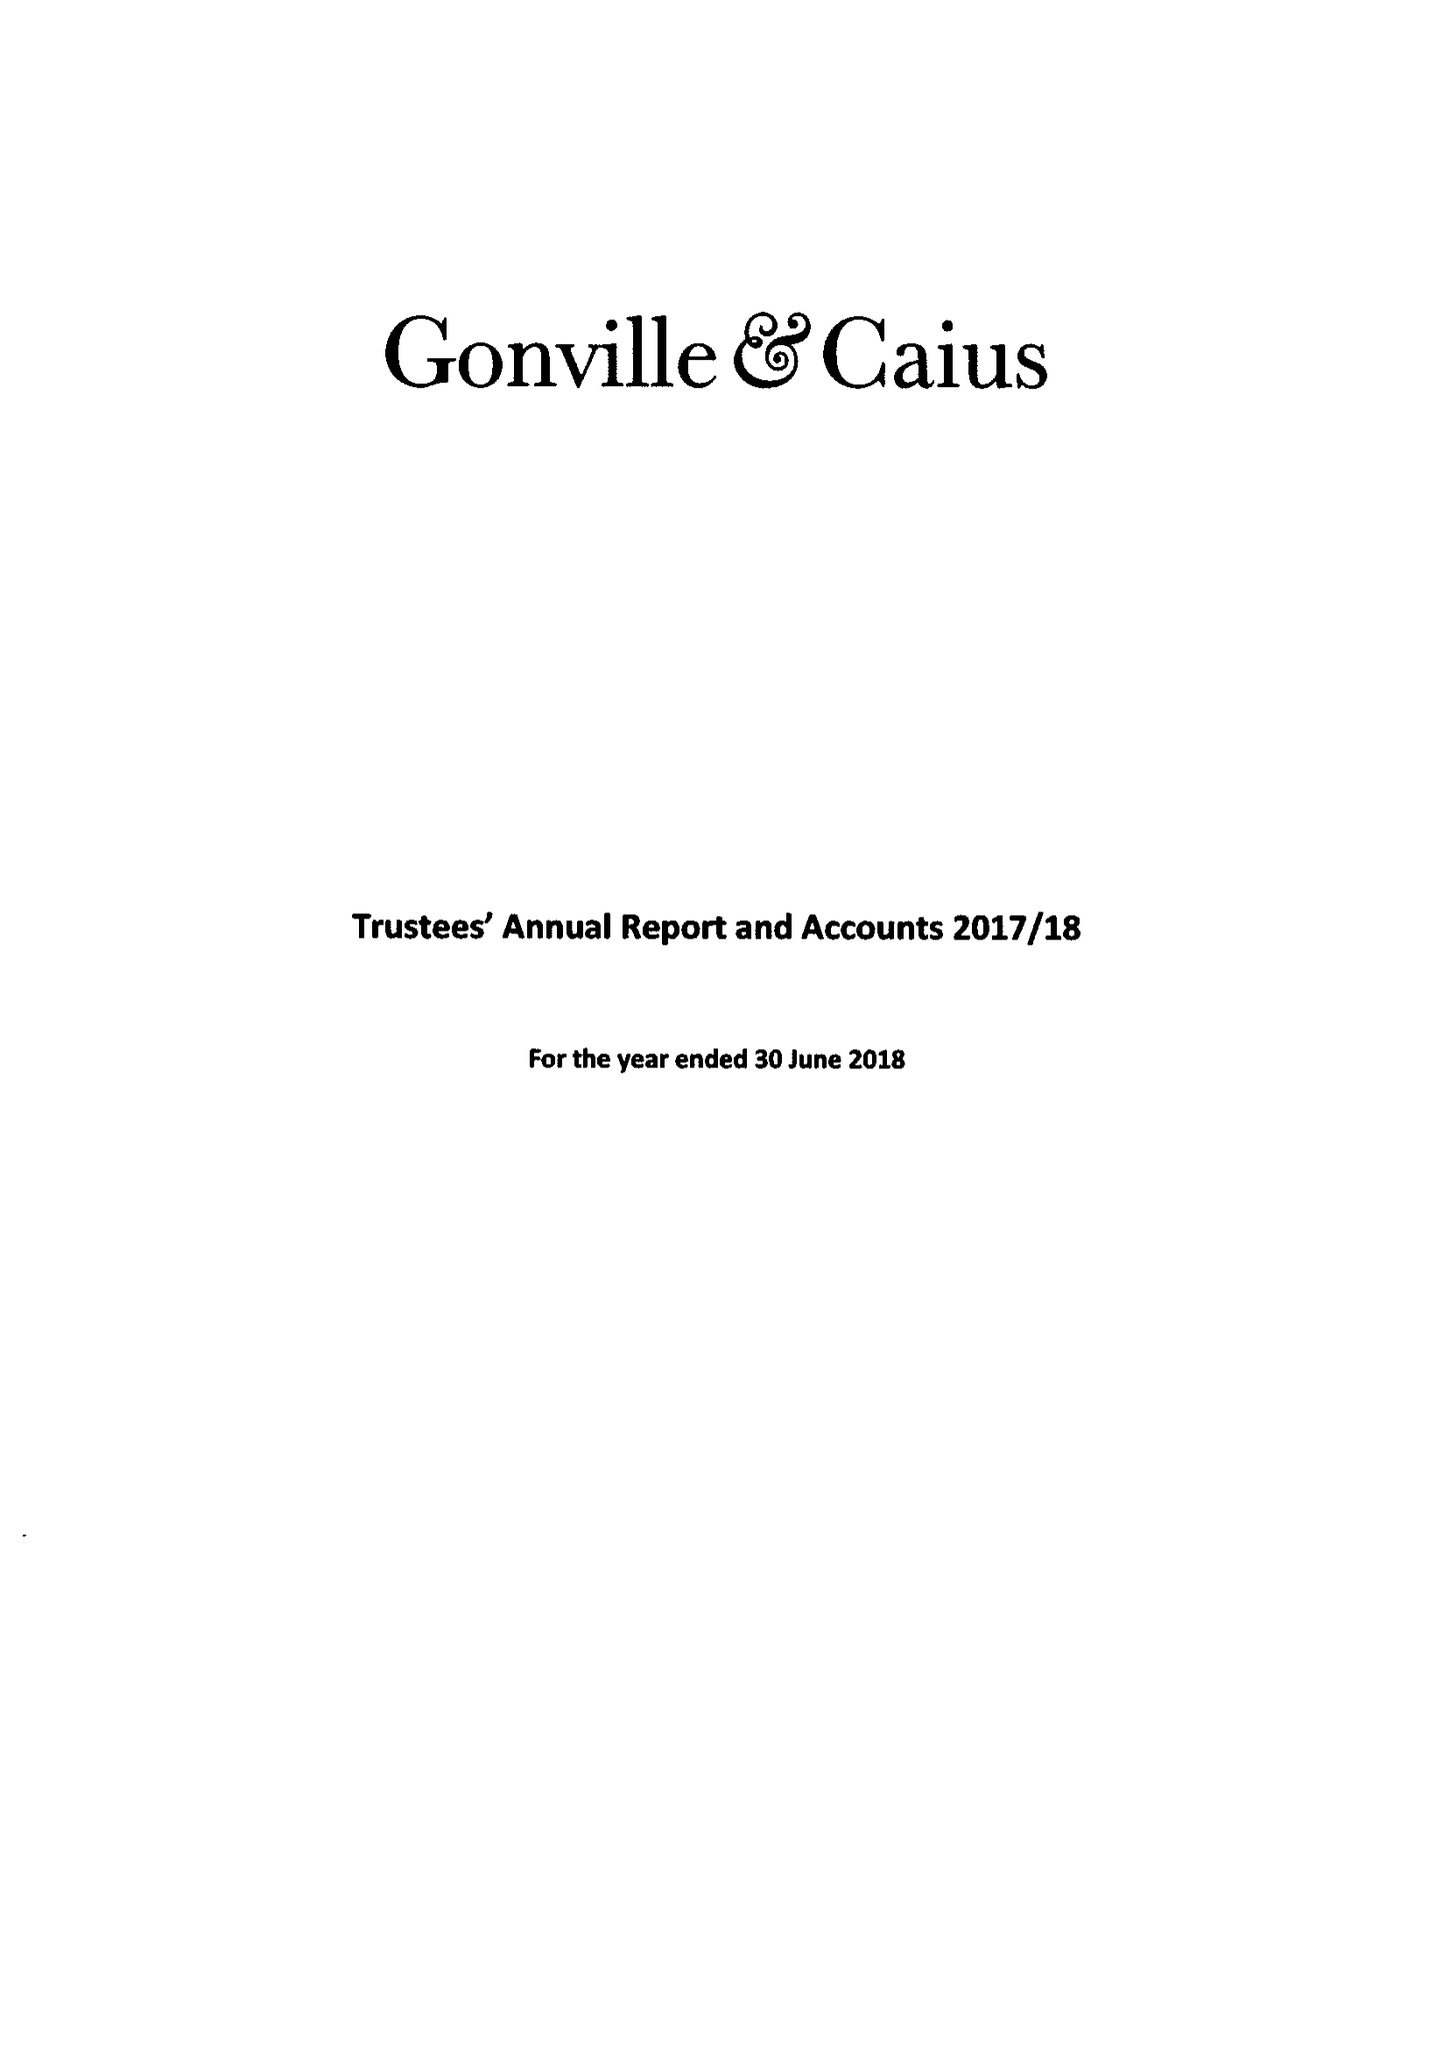What is the value for the charity_name?
Answer the question using a single word or phrase. Gonville and Caius College 